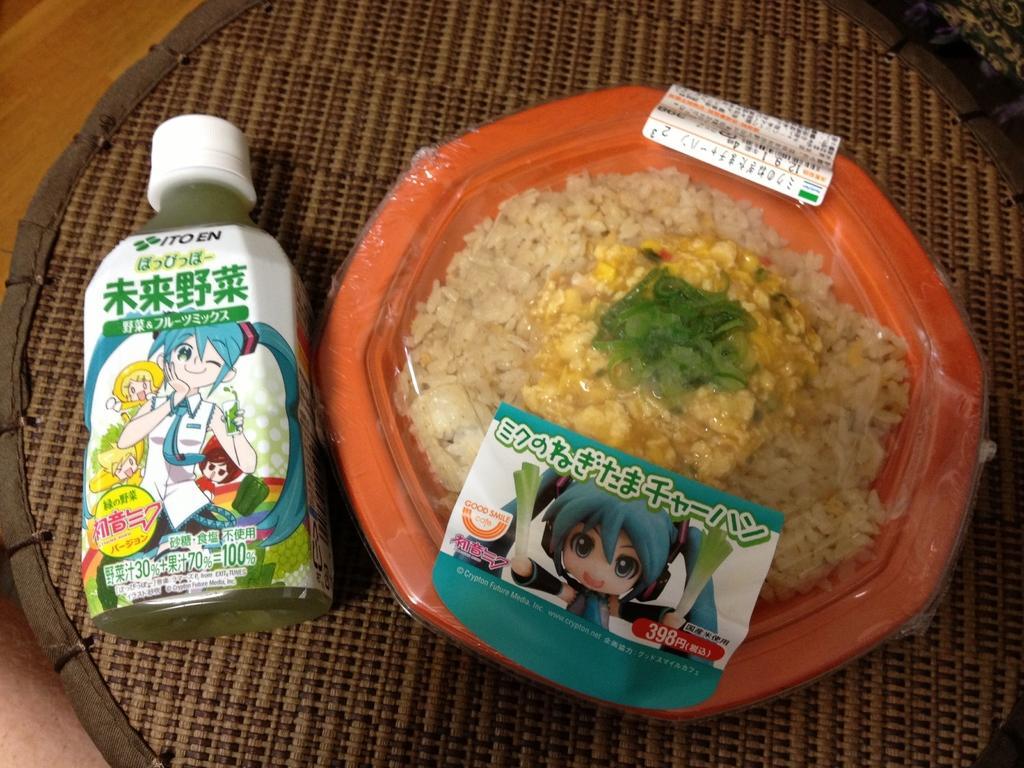Could you give a brief overview of what you see in this image? In this image we can see a bottle and some food in a bowl covered with a polythene cover kept on a mat which is placed on the surface. 